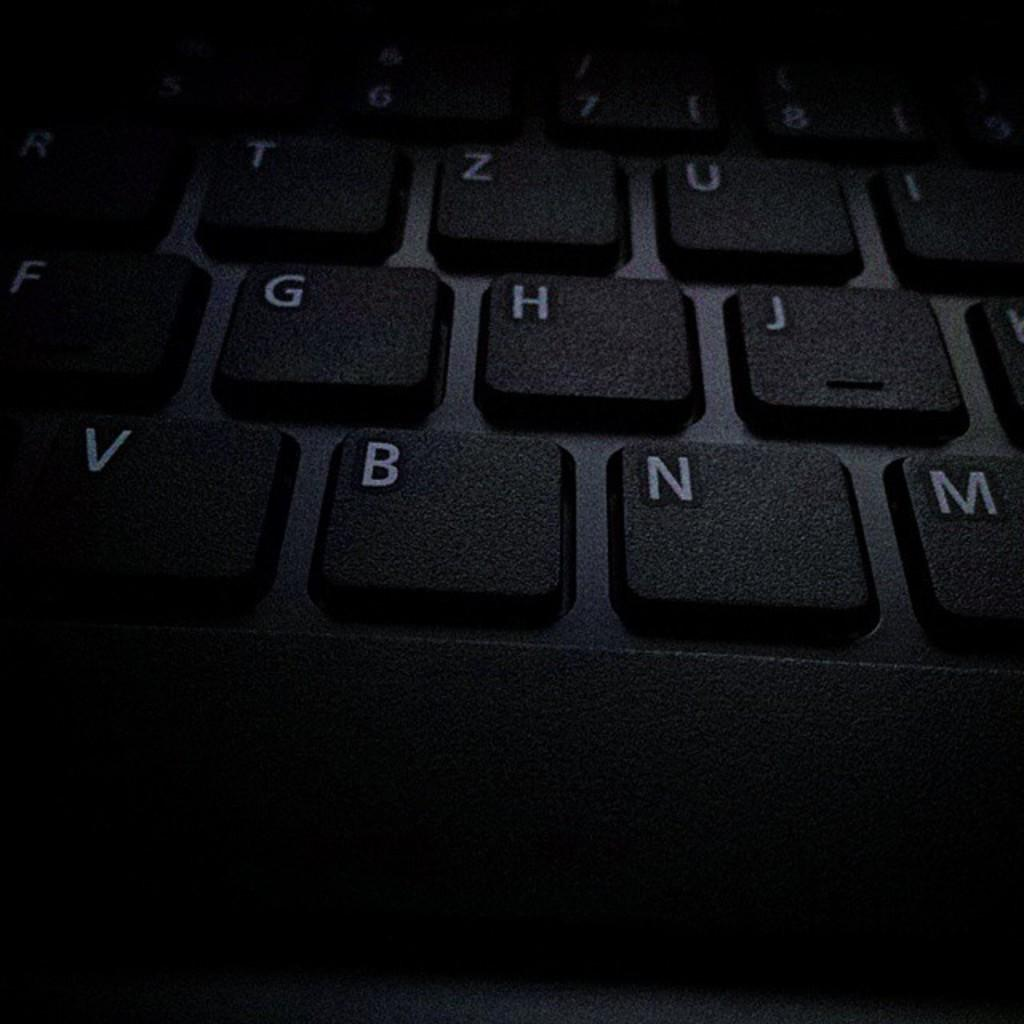What type of device is visible in the image? There is a black color keyboard in the image. What can be seen on the keys of the keyboard? Numbers and alphabets are visible on the keyboard. Where is the nearest playground to the location of the keyboard in the image? The image does not provide information about the location of the keyboard or the presence of a playground nearby. 